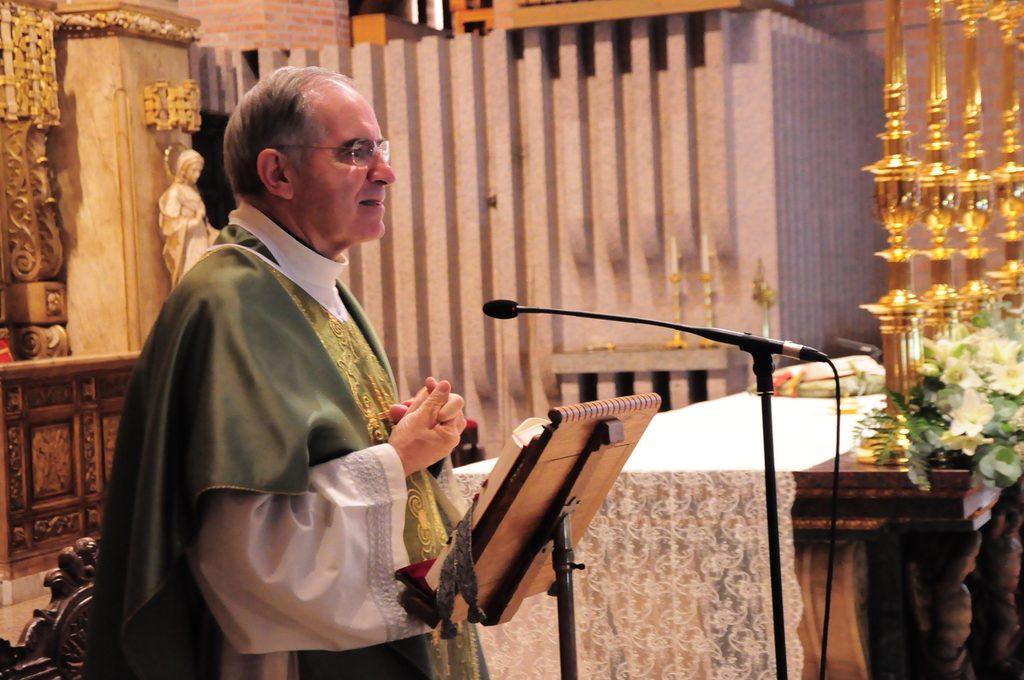In one or two sentences, can you explain what this image depicts? In this image there is a man standing, in front of him there is a book and a mike, in the background there is a table on that table there is a cloth and metal items and there is a wall for that wall there are carvings. 